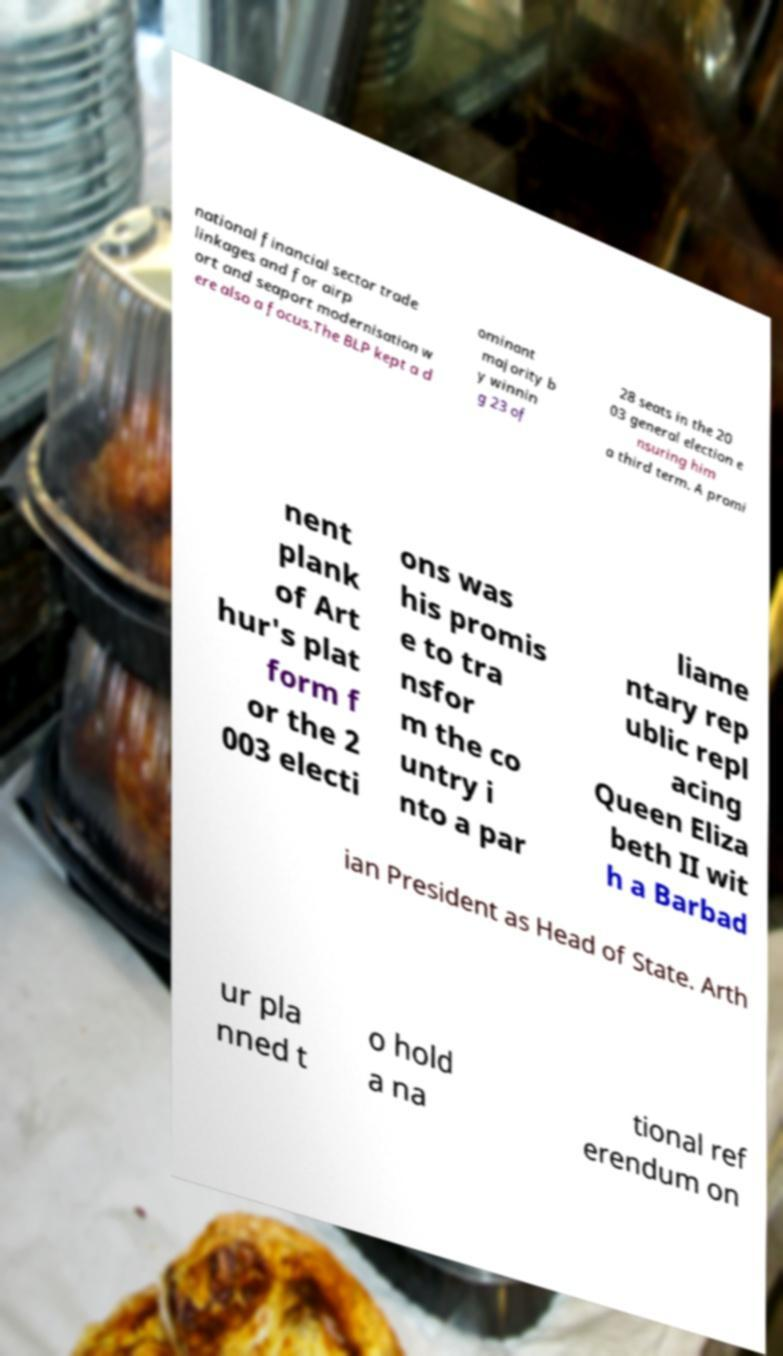I need the written content from this picture converted into text. Can you do that? national financial sector trade linkages and for airp ort and seaport modernisation w ere also a focus.The BLP kept a d ominant majority b y winnin g 23 of 28 seats in the 20 03 general election e nsuring him a third term. A promi nent plank of Art hur's plat form f or the 2 003 electi ons was his promis e to tra nsfor m the co untry i nto a par liame ntary rep ublic repl acing Queen Eliza beth II wit h a Barbad ian President as Head of State. Arth ur pla nned t o hold a na tional ref erendum on 